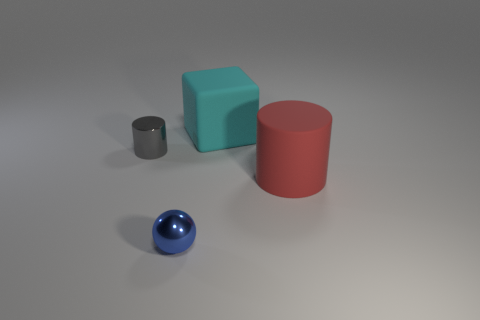How many spheres are red things or gray metal objects?
Make the answer very short. 0. There is a blue object; does it have the same shape as the big matte thing behind the large red cylinder?
Make the answer very short. No. How many red matte objects have the same size as the cyan thing?
Ensure brevity in your answer.  1. There is a tiny blue object that is in front of the cyan matte thing; does it have the same shape as the red rubber thing that is behind the blue sphere?
Ensure brevity in your answer.  No. The large thing in front of the large thing that is behind the gray metal thing is what color?
Give a very brief answer. Red. What is the color of the other metal thing that is the same shape as the large red thing?
Your response must be concise. Gray. Is there any other thing that is the same material as the tiny sphere?
Keep it short and to the point. Yes. There is a gray shiny object that is the same shape as the red rubber object; what is its size?
Ensure brevity in your answer.  Small. What is the material of the thing on the left side of the tiny blue sphere?
Offer a very short reply. Metal. Is the number of tiny things that are in front of the red cylinder less than the number of large cylinders?
Give a very brief answer. No. 